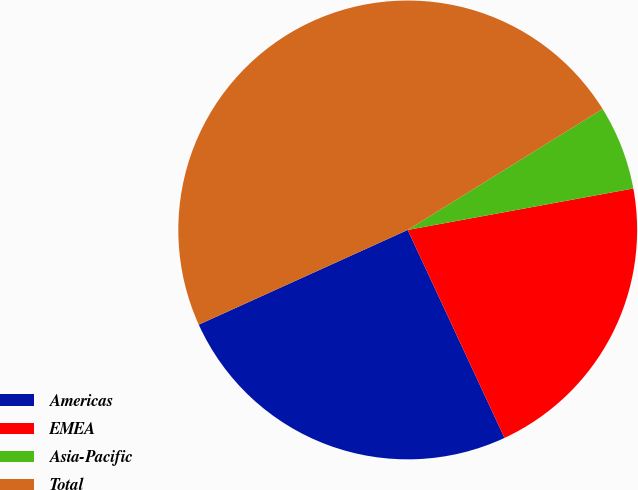Convert chart. <chart><loc_0><loc_0><loc_500><loc_500><pie_chart><fcel>Americas<fcel>EMEA<fcel>Asia-Pacific<fcel>Total<nl><fcel>25.16%<fcel>20.96%<fcel>5.95%<fcel>47.93%<nl></chart> 